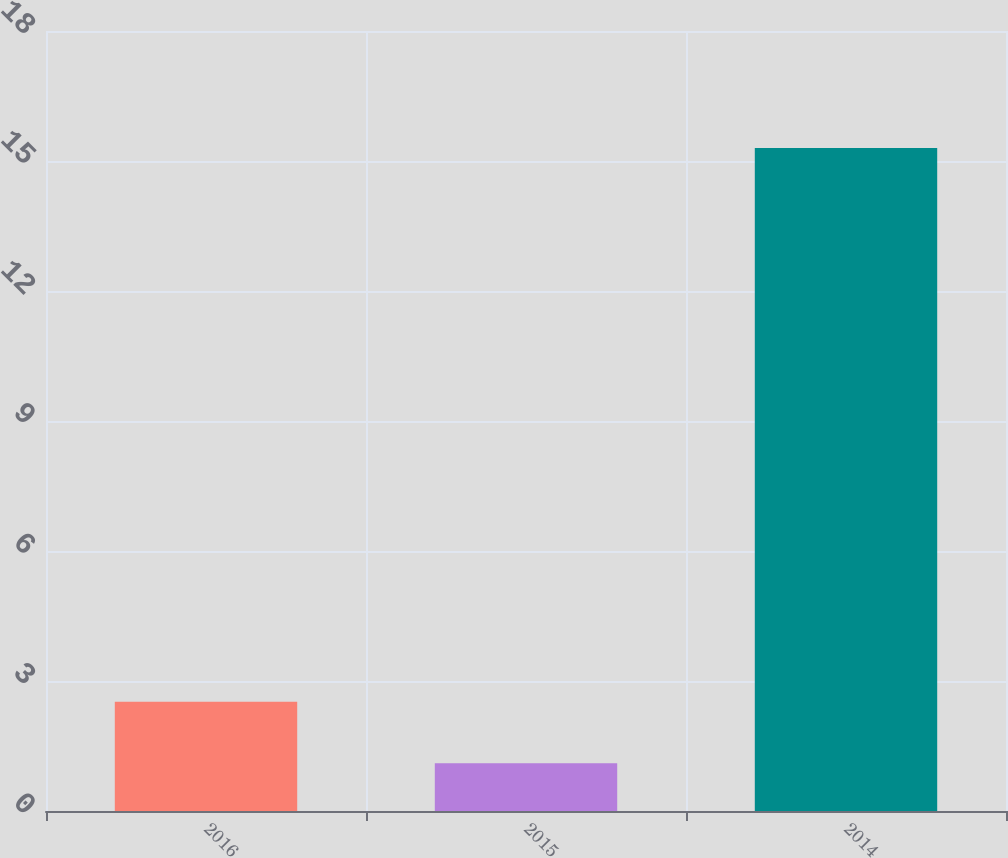Convert chart. <chart><loc_0><loc_0><loc_500><loc_500><bar_chart><fcel>2016<fcel>2015<fcel>2014<nl><fcel>2.52<fcel>1.1<fcel>15.3<nl></chart> 